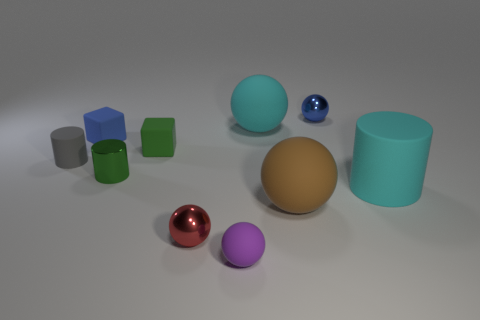What number of other objects are there of the same shape as the small purple object?
Offer a very short reply. 4. There is a small blue shiny thing to the right of the gray rubber thing; is it the same shape as the large brown thing that is behind the tiny purple matte sphere?
Provide a succinct answer. Yes. How many spheres are large rubber objects or green metal things?
Make the answer very short. 2. What material is the tiny thing behind the big cyan thing that is on the left side of the small metal thing that is behind the gray rubber thing?
Your answer should be compact. Metal. How many other objects are there of the same size as the green rubber object?
Provide a short and direct response. 6. There is a sphere that is the same color as the large matte cylinder; what is its size?
Your response must be concise. Large. Are there more blue things that are in front of the big cyan cylinder than blue shiny balls?
Make the answer very short. No. Are there any blocks of the same color as the tiny matte ball?
Offer a very short reply. No. There is a rubber cylinder that is the same size as the green metal object; what is its color?
Give a very brief answer. Gray. There is a cyan rubber thing in front of the small green block; how many blue rubber blocks are on the right side of it?
Keep it short and to the point. 0. 